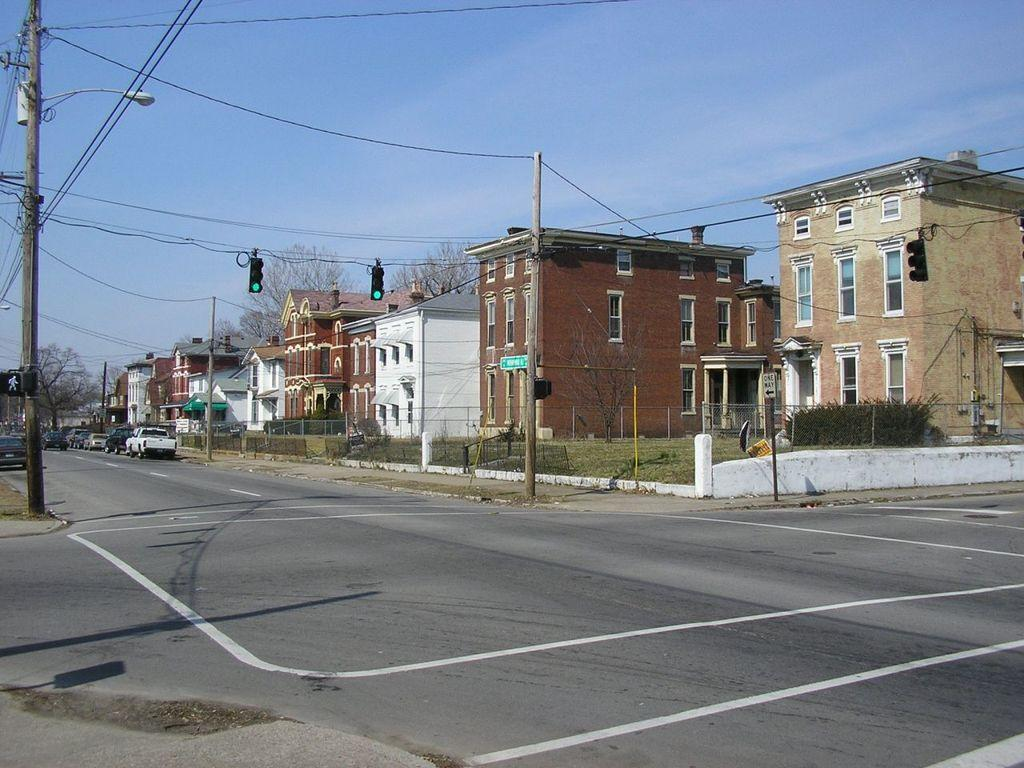What is happening on the road in the image? There are vehicles on the road in the image. What helps regulate the traffic in the image? Traffic signal lights are present in the image. What type of structures can be seen in the image? There are buildings with windows in the image. What is separating the road from the sidewalk in the image? A fence is visible in the image. What type of vegetation is present in the image? Trees are present in the image. What are the tall, thin structures in the image? Poles are visible in the image. What can be seen in the background of the image? The sky with clouds is visible in the background of the image. What type of company is being advertised on the celery in the image? There is no celery present in the image, and therefore no company can be advertised on it. 